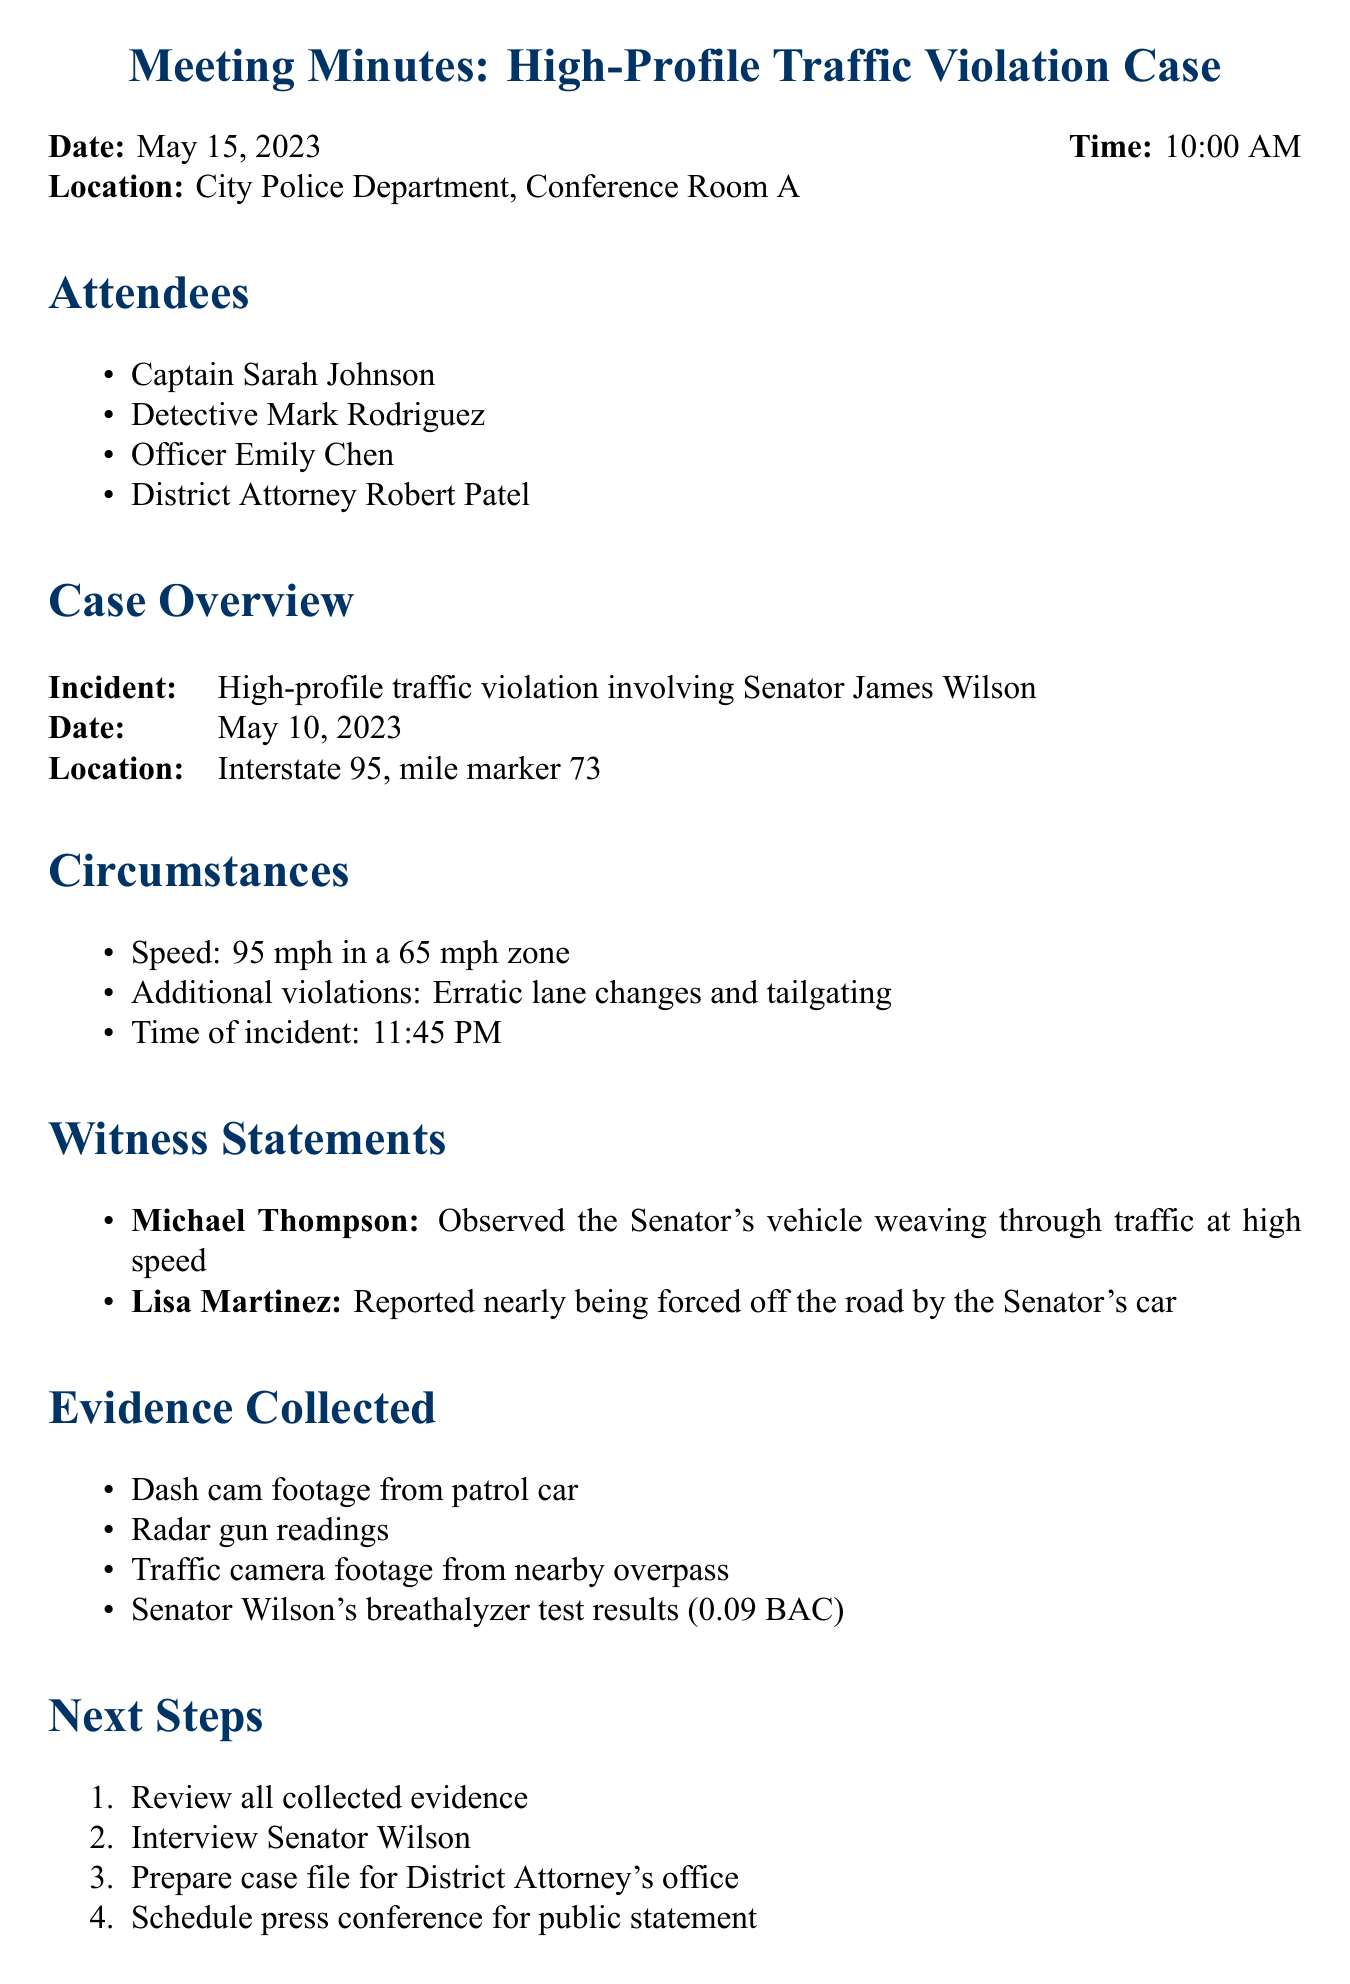What is the date of the incident? The date of the incident refers to when the traffic violation occurred, which is specified in the case overview.
Answer: May 10, 2023 What was the speed of Senator Wilson's vehicle? The speed is mentioned in the circumstances section of the document, detailing how fast the vehicle was traveling.
Answer: 95 mph Who reported nearly being forced off the road? This question inquires about the witness who made this statement, which is documented in the witness statements section.
Answer: Lisa Martinez What kind of evidence was collected from the patrol car? This asks for specific types of evidence, indicating what was gathered during the investigation, found in the evidence section.
Answer: Dash cam footage What are the potential charges against Senator Wilson? This question seeks to clarify what charges might be applied based on the circumstances and evidence, as listed in the document.
Answer: Reckless driving At what time did the incident occur? This identifies the exact time related to the traffic violation, provided in the circumstances section.
Answer: 11:45 PM Which law enforcement official is the District Attorney? This question asks for the name of the specific attendee at the meeting serving as the District Attorney.
Answer: Robert Patel What is the location of the incident? It seeks to find out where the traffic violation happened, as outlined in the case overview.
Answer: Interstate 95, mile marker 73 